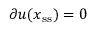Convert formula to latex. <formula><loc_0><loc_0><loc_500><loc_500>\partial \boldsymbol u ( x _ { s s } ) = 0</formula> 